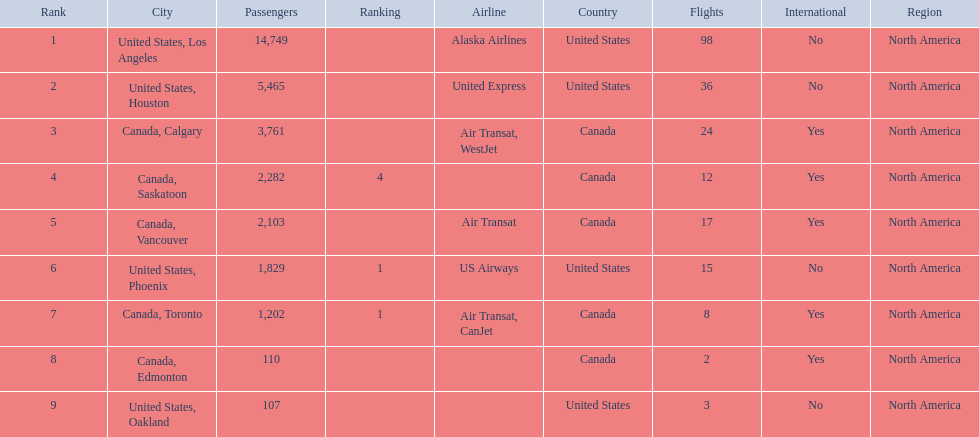What are the cities flown to? United States, Los Angeles, United States, Houston, Canada, Calgary, Canada, Saskatoon, Canada, Vancouver, United States, Phoenix, Canada, Toronto, Canada, Edmonton, United States, Oakland. What number of passengers did pheonix have? 1,829. 